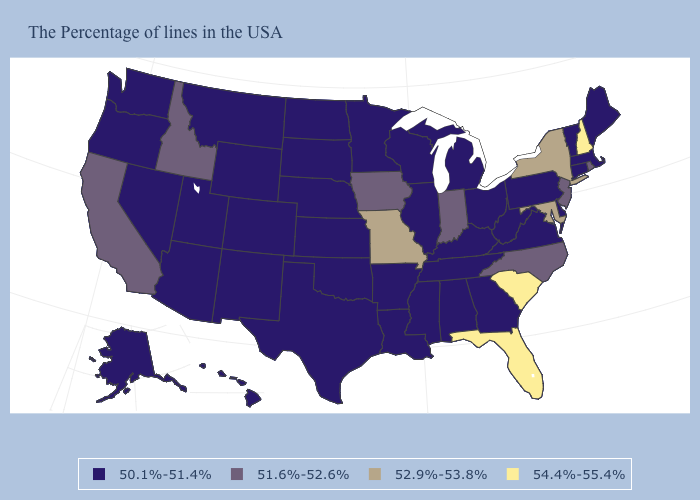Name the states that have a value in the range 51.6%-52.6%?
Write a very short answer. Rhode Island, New Jersey, North Carolina, Indiana, Iowa, Idaho, California. What is the value of Idaho?
Quick response, please. 51.6%-52.6%. What is the value of Kansas?
Quick response, please. 50.1%-51.4%. Name the states that have a value in the range 51.6%-52.6%?
Quick response, please. Rhode Island, New Jersey, North Carolina, Indiana, Iowa, Idaho, California. Does South Carolina have the lowest value in the South?
Write a very short answer. No. Among the states that border Rhode Island , which have the highest value?
Write a very short answer. Massachusetts, Connecticut. What is the value of Minnesota?
Be succinct. 50.1%-51.4%. Does New Hampshire have the lowest value in the Northeast?
Give a very brief answer. No. What is the value of South Dakota?
Concise answer only. 50.1%-51.4%. What is the value of Indiana?
Short answer required. 51.6%-52.6%. What is the value of Alaska?
Be succinct. 50.1%-51.4%. What is the lowest value in states that border Illinois?
Concise answer only. 50.1%-51.4%. Is the legend a continuous bar?
Give a very brief answer. No. What is the value of North Dakota?
Concise answer only. 50.1%-51.4%. Among the states that border West Virginia , does Pennsylvania have the highest value?
Give a very brief answer. No. 